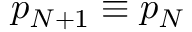Convert formula to latex. <formula><loc_0><loc_0><loc_500><loc_500>p _ { N + 1 } \equiv p _ { N }</formula> 